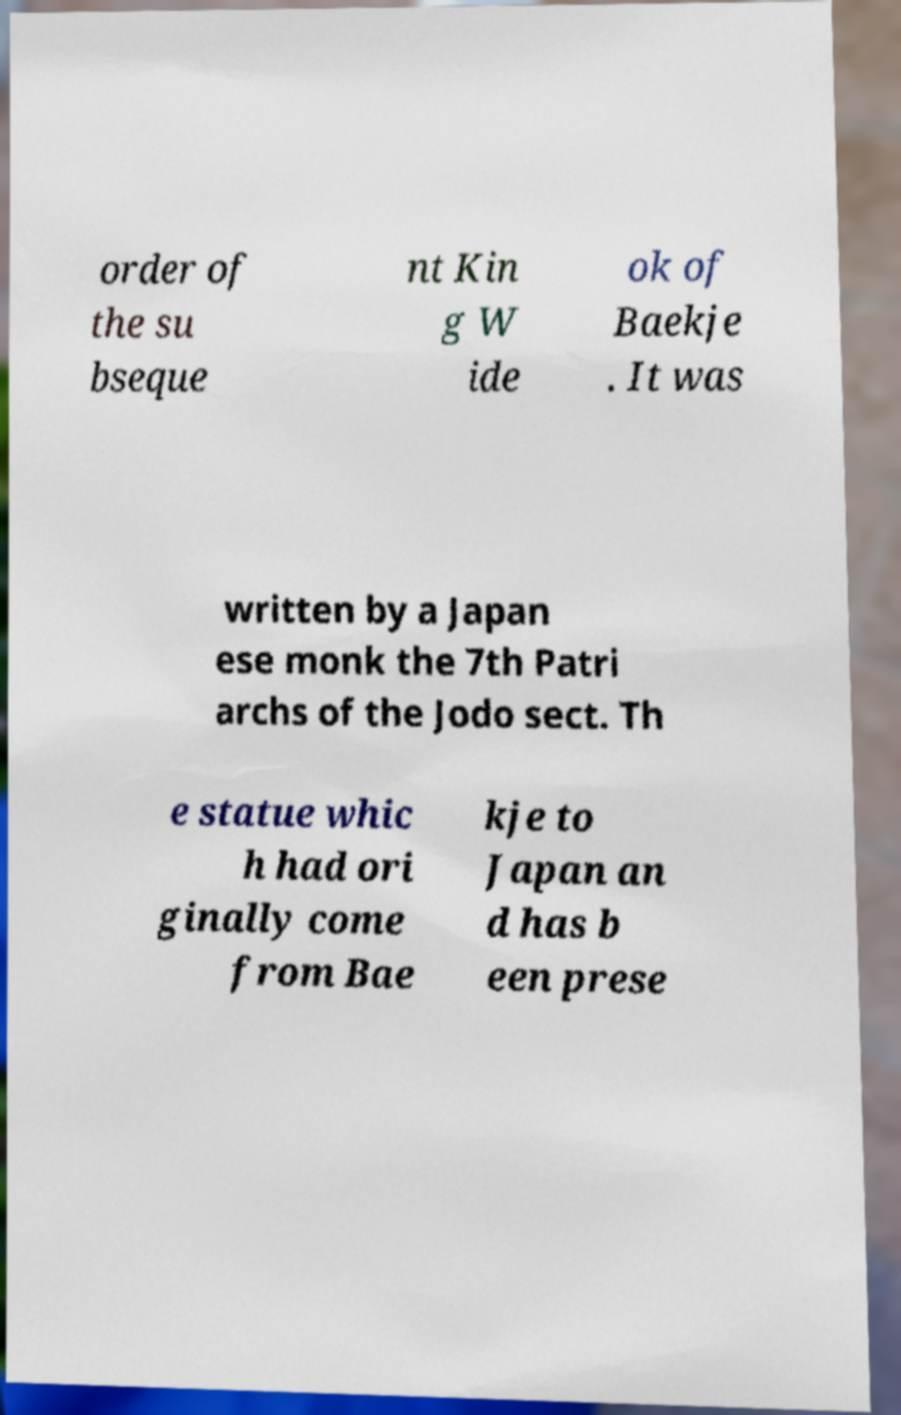Please identify and transcribe the text found in this image. order of the su bseque nt Kin g W ide ok of Baekje . It was written by a Japan ese monk the 7th Patri archs of the Jodo sect. Th e statue whic h had ori ginally come from Bae kje to Japan an d has b een prese 